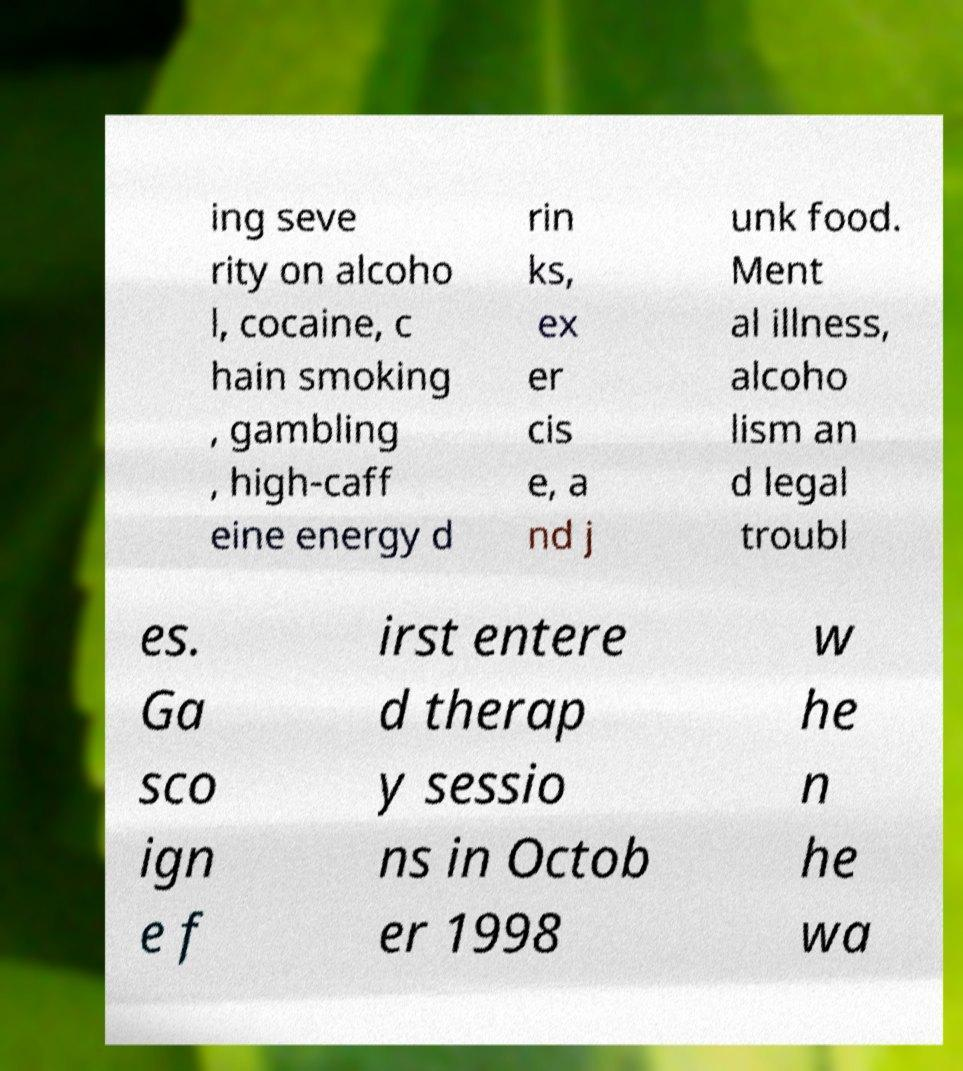Could you assist in decoding the text presented in this image and type it out clearly? ing seve rity on alcoho l, cocaine, c hain smoking , gambling , high-caff eine energy d rin ks, ex er cis e, a nd j unk food. Ment al illness, alcoho lism an d legal troubl es. Ga sco ign e f irst entere d therap y sessio ns in Octob er 1998 w he n he wa 